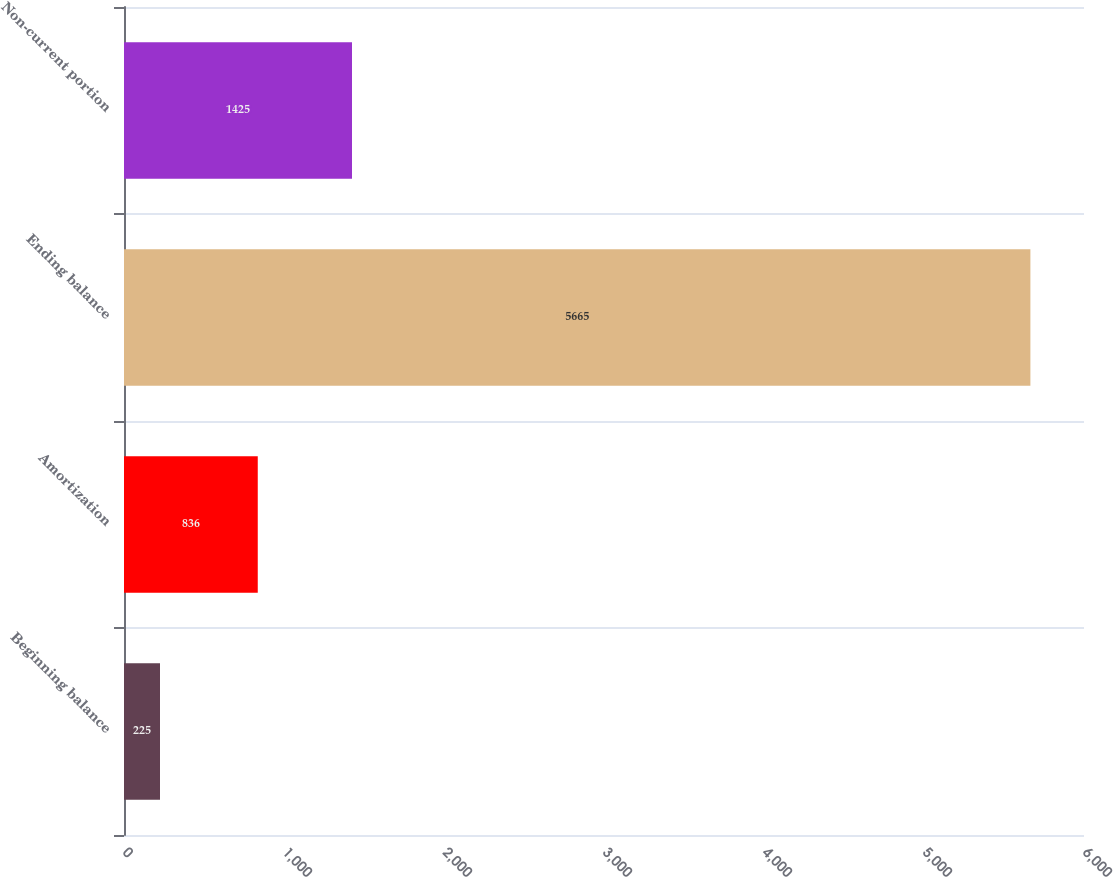<chart> <loc_0><loc_0><loc_500><loc_500><bar_chart><fcel>Beginning balance<fcel>Amortization<fcel>Ending balance<fcel>Non-current portion<nl><fcel>225<fcel>836<fcel>5665<fcel>1425<nl></chart> 